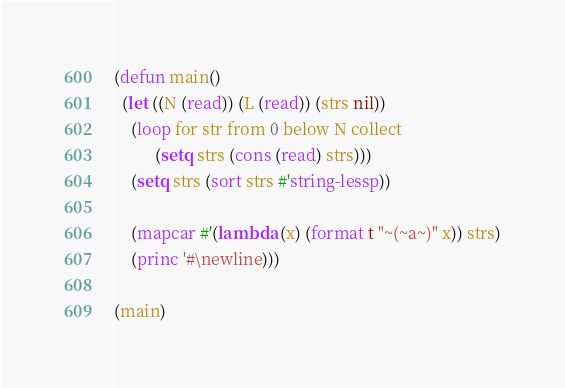<code> <loc_0><loc_0><loc_500><loc_500><_Lisp_>(defun main()
  (let ((N (read)) (L (read)) (strs nil))
    (loop for str from 0 below N collect
          (setq strs (cons (read) strs)))
    (setq strs (sort strs #'string-lessp))

    (mapcar #'(lambda (x) (format t "~(~a~)" x)) strs)
    (princ '#\newline)))

(main)</code> 